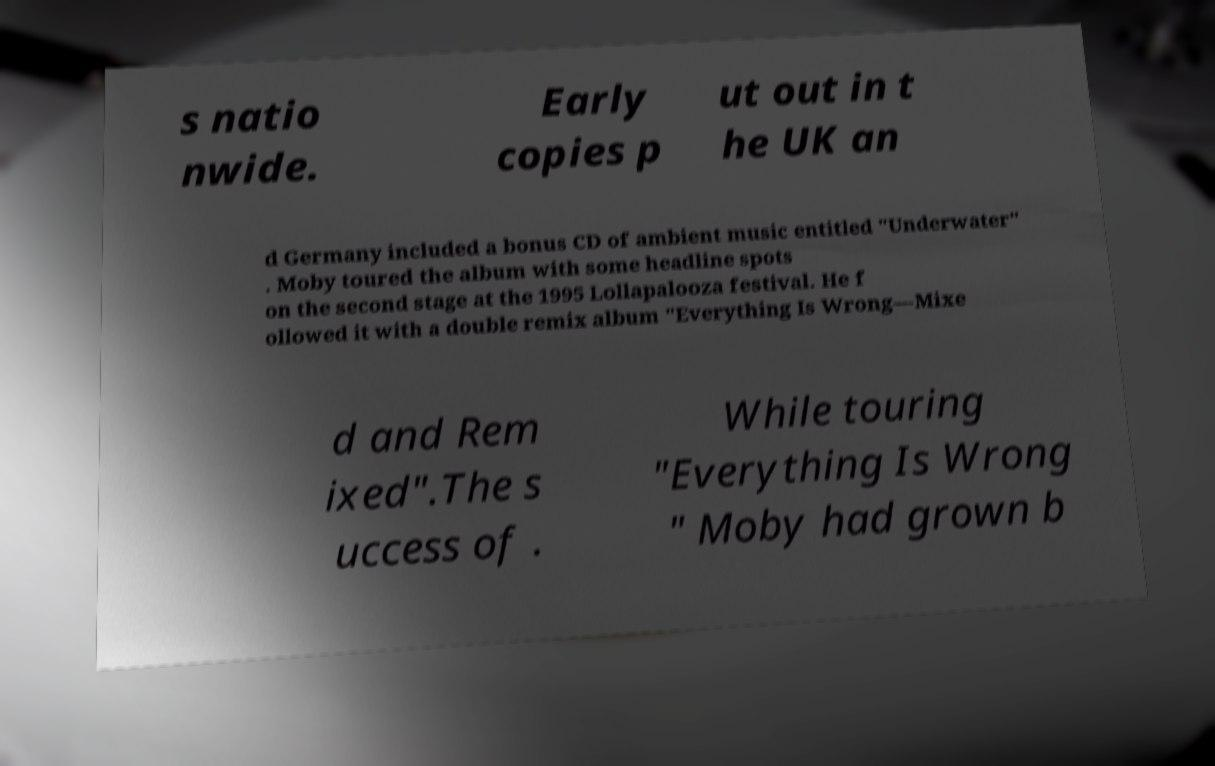What messages or text are displayed in this image? I need them in a readable, typed format. s natio nwide. Early copies p ut out in t he UK an d Germany included a bonus CD of ambient music entitled "Underwater" . Moby toured the album with some headline spots on the second stage at the 1995 Lollapalooza festival. He f ollowed it with a double remix album "Everything Is Wrong—Mixe d and Rem ixed".The s uccess of . While touring "Everything Is Wrong " Moby had grown b 